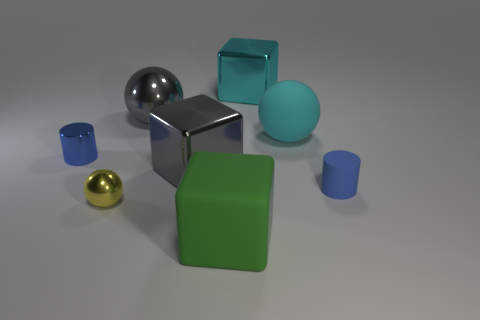The matte object that is behind the cylinder that is on the right side of the cyan cube on the right side of the large gray metallic block is what color?
Keep it short and to the point. Cyan. The shiny cylinder is what color?
Give a very brief answer. Blue. Is the number of big matte objects that are behind the tiny blue rubber object greater than the number of yellow shiny things that are behind the large gray shiny cube?
Your response must be concise. Yes. Is the shape of the cyan rubber thing the same as the gray metallic thing that is behind the small metal cylinder?
Provide a short and direct response. Yes. There is a cylinder to the right of the green block; is it the same size as the yellow ball that is in front of the blue shiny cylinder?
Your answer should be very brief. Yes. Are there any big gray balls that are on the left side of the blue cylinder left of the small blue cylinder on the right side of the large cyan metallic object?
Your answer should be compact. No. Is the number of blue cylinders to the right of the small yellow ball less than the number of large objects that are on the right side of the big gray block?
Your answer should be compact. Yes. There is a cyan thing that is made of the same material as the large green block; what is its shape?
Provide a succinct answer. Sphere. There is a matte thing that is in front of the cylinder that is on the right side of the cylinder that is on the left side of the big gray metal cube; what is its size?
Offer a very short reply. Large. Are there more blue cylinders than big objects?
Keep it short and to the point. No. 